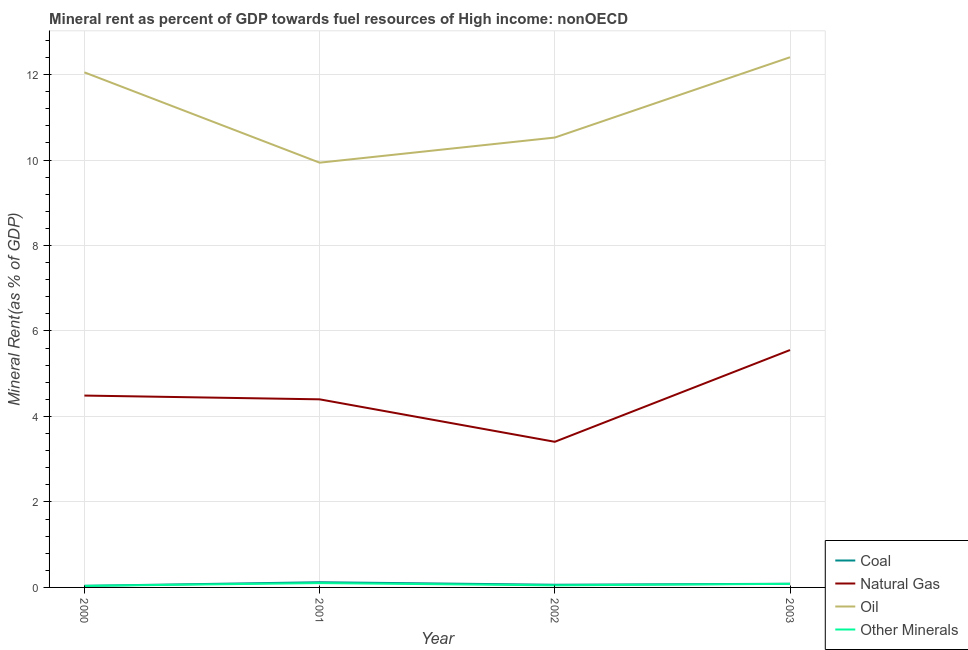How many different coloured lines are there?
Offer a very short reply. 4. What is the natural gas rent in 2001?
Offer a terse response. 4.4. Across all years, what is the maximum coal rent?
Your response must be concise. 0.12. Across all years, what is the minimum coal rent?
Give a very brief answer. 0.04. In which year was the coal rent maximum?
Make the answer very short. 2001. In which year was the oil rent minimum?
Your response must be concise. 2001. What is the total  rent of other minerals in the graph?
Your answer should be compact. 0.27. What is the difference between the oil rent in 2001 and that in 2002?
Your answer should be compact. -0.59. What is the difference between the oil rent in 2000 and the natural gas rent in 2003?
Keep it short and to the point. 6.5. What is the average  rent of other minerals per year?
Ensure brevity in your answer.  0.07. In the year 2000, what is the difference between the natural gas rent and coal rent?
Give a very brief answer. 4.45. In how many years, is the  rent of other minerals greater than 8.4 %?
Offer a terse response. 0. What is the ratio of the coal rent in 2000 to that in 2003?
Your response must be concise. 0.43. What is the difference between the highest and the second highest oil rent?
Make the answer very short. 0.35. What is the difference between the highest and the lowest coal rent?
Make the answer very short. 0.08. In how many years, is the  rent of other minerals greater than the average  rent of other minerals taken over all years?
Provide a short and direct response. 2. Is it the case that in every year, the sum of the coal rent and natural gas rent is greater than the oil rent?
Ensure brevity in your answer.  No. Is the natural gas rent strictly less than the coal rent over the years?
Your answer should be compact. No. How many years are there in the graph?
Your answer should be very brief. 4. Where does the legend appear in the graph?
Offer a terse response. Bottom right. What is the title of the graph?
Provide a succinct answer. Mineral rent as percent of GDP towards fuel resources of High income: nonOECD. What is the label or title of the X-axis?
Offer a very short reply. Year. What is the label or title of the Y-axis?
Keep it short and to the point. Mineral Rent(as % of GDP). What is the Mineral Rent(as % of GDP) in Coal in 2000?
Your answer should be compact. 0.04. What is the Mineral Rent(as % of GDP) in Natural Gas in 2000?
Offer a very short reply. 4.49. What is the Mineral Rent(as % of GDP) of Oil in 2000?
Keep it short and to the point. 12.05. What is the Mineral Rent(as % of GDP) of Other Minerals in 2000?
Offer a terse response. 0.04. What is the Mineral Rent(as % of GDP) of Coal in 2001?
Provide a short and direct response. 0.12. What is the Mineral Rent(as % of GDP) of Natural Gas in 2001?
Provide a short and direct response. 4.4. What is the Mineral Rent(as % of GDP) in Oil in 2001?
Your answer should be very brief. 9.94. What is the Mineral Rent(as % of GDP) in Other Minerals in 2001?
Give a very brief answer. 0.1. What is the Mineral Rent(as % of GDP) of Coal in 2002?
Make the answer very short. 0.06. What is the Mineral Rent(as % of GDP) in Natural Gas in 2002?
Your response must be concise. 3.41. What is the Mineral Rent(as % of GDP) of Oil in 2002?
Make the answer very short. 10.53. What is the Mineral Rent(as % of GDP) in Other Minerals in 2002?
Make the answer very short. 0.05. What is the Mineral Rent(as % of GDP) in Coal in 2003?
Provide a short and direct response. 0.09. What is the Mineral Rent(as % of GDP) of Natural Gas in 2003?
Make the answer very short. 5.55. What is the Mineral Rent(as % of GDP) in Oil in 2003?
Your answer should be compact. 12.4. What is the Mineral Rent(as % of GDP) in Other Minerals in 2003?
Your answer should be very brief. 0.08. Across all years, what is the maximum Mineral Rent(as % of GDP) in Coal?
Your response must be concise. 0.12. Across all years, what is the maximum Mineral Rent(as % of GDP) of Natural Gas?
Provide a succinct answer. 5.55. Across all years, what is the maximum Mineral Rent(as % of GDP) of Oil?
Make the answer very short. 12.4. Across all years, what is the maximum Mineral Rent(as % of GDP) in Other Minerals?
Give a very brief answer. 0.1. Across all years, what is the minimum Mineral Rent(as % of GDP) of Coal?
Make the answer very short. 0.04. Across all years, what is the minimum Mineral Rent(as % of GDP) of Natural Gas?
Give a very brief answer. 3.41. Across all years, what is the minimum Mineral Rent(as % of GDP) in Oil?
Your answer should be very brief. 9.94. Across all years, what is the minimum Mineral Rent(as % of GDP) of Other Minerals?
Offer a very short reply. 0.04. What is the total Mineral Rent(as % of GDP) in Coal in the graph?
Make the answer very short. 0.31. What is the total Mineral Rent(as % of GDP) of Natural Gas in the graph?
Make the answer very short. 17.85. What is the total Mineral Rent(as % of GDP) in Oil in the graph?
Your answer should be compact. 44.92. What is the total Mineral Rent(as % of GDP) in Other Minerals in the graph?
Provide a short and direct response. 0.27. What is the difference between the Mineral Rent(as % of GDP) of Coal in 2000 and that in 2001?
Provide a short and direct response. -0.08. What is the difference between the Mineral Rent(as % of GDP) of Natural Gas in 2000 and that in 2001?
Ensure brevity in your answer.  0.09. What is the difference between the Mineral Rent(as % of GDP) of Oil in 2000 and that in 2001?
Provide a succinct answer. 2.11. What is the difference between the Mineral Rent(as % of GDP) of Other Minerals in 2000 and that in 2001?
Keep it short and to the point. -0.07. What is the difference between the Mineral Rent(as % of GDP) in Coal in 2000 and that in 2002?
Offer a terse response. -0.03. What is the difference between the Mineral Rent(as % of GDP) in Natural Gas in 2000 and that in 2002?
Keep it short and to the point. 1.08. What is the difference between the Mineral Rent(as % of GDP) in Oil in 2000 and that in 2002?
Make the answer very short. 1.53. What is the difference between the Mineral Rent(as % of GDP) in Other Minerals in 2000 and that in 2002?
Your response must be concise. -0.01. What is the difference between the Mineral Rent(as % of GDP) in Coal in 2000 and that in 2003?
Make the answer very short. -0.05. What is the difference between the Mineral Rent(as % of GDP) in Natural Gas in 2000 and that in 2003?
Offer a terse response. -1.07. What is the difference between the Mineral Rent(as % of GDP) in Oil in 2000 and that in 2003?
Ensure brevity in your answer.  -0.35. What is the difference between the Mineral Rent(as % of GDP) in Other Minerals in 2000 and that in 2003?
Give a very brief answer. -0.05. What is the difference between the Mineral Rent(as % of GDP) in Coal in 2001 and that in 2002?
Make the answer very short. 0.06. What is the difference between the Mineral Rent(as % of GDP) of Natural Gas in 2001 and that in 2002?
Your answer should be very brief. 0.99. What is the difference between the Mineral Rent(as % of GDP) of Oil in 2001 and that in 2002?
Provide a succinct answer. -0.59. What is the difference between the Mineral Rent(as % of GDP) of Other Minerals in 2001 and that in 2002?
Offer a very short reply. 0.05. What is the difference between the Mineral Rent(as % of GDP) in Coal in 2001 and that in 2003?
Your answer should be compact. 0.04. What is the difference between the Mineral Rent(as % of GDP) in Natural Gas in 2001 and that in 2003?
Ensure brevity in your answer.  -1.15. What is the difference between the Mineral Rent(as % of GDP) in Oil in 2001 and that in 2003?
Provide a short and direct response. -2.47. What is the difference between the Mineral Rent(as % of GDP) in Other Minerals in 2001 and that in 2003?
Provide a short and direct response. 0.02. What is the difference between the Mineral Rent(as % of GDP) of Coal in 2002 and that in 2003?
Offer a very short reply. -0.02. What is the difference between the Mineral Rent(as % of GDP) of Natural Gas in 2002 and that in 2003?
Provide a short and direct response. -2.15. What is the difference between the Mineral Rent(as % of GDP) of Oil in 2002 and that in 2003?
Keep it short and to the point. -1.88. What is the difference between the Mineral Rent(as % of GDP) of Other Minerals in 2002 and that in 2003?
Your answer should be very brief. -0.04. What is the difference between the Mineral Rent(as % of GDP) of Coal in 2000 and the Mineral Rent(as % of GDP) of Natural Gas in 2001?
Your response must be concise. -4.36. What is the difference between the Mineral Rent(as % of GDP) in Coal in 2000 and the Mineral Rent(as % of GDP) in Oil in 2001?
Provide a short and direct response. -9.9. What is the difference between the Mineral Rent(as % of GDP) of Coal in 2000 and the Mineral Rent(as % of GDP) of Other Minerals in 2001?
Give a very brief answer. -0.06. What is the difference between the Mineral Rent(as % of GDP) of Natural Gas in 2000 and the Mineral Rent(as % of GDP) of Oil in 2001?
Provide a succinct answer. -5.45. What is the difference between the Mineral Rent(as % of GDP) in Natural Gas in 2000 and the Mineral Rent(as % of GDP) in Other Minerals in 2001?
Give a very brief answer. 4.39. What is the difference between the Mineral Rent(as % of GDP) of Oil in 2000 and the Mineral Rent(as % of GDP) of Other Minerals in 2001?
Provide a short and direct response. 11.95. What is the difference between the Mineral Rent(as % of GDP) in Coal in 2000 and the Mineral Rent(as % of GDP) in Natural Gas in 2002?
Ensure brevity in your answer.  -3.37. What is the difference between the Mineral Rent(as % of GDP) of Coal in 2000 and the Mineral Rent(as % of GDP) of Oil in 2002?
Ensure brevity in your answer.  -10.49. What is the difference between the Mineral Rent(as % of GDP) of Coal in 2000 and the Mineral Rent(as % of GDP) of Other Minerals in 2002?
Your answer should be compact. -0.01. What is the difference between the Mineral Rent(as % of GDP) in Natural Gas in 2000 and the Mineral Rent(as % of GDP) in Oil in 2002?
Give a very brief answer. -6.04. What is the difference between the Mineral Rent(as % of GDP) of Natural Gas in 2000 and the Mineral Rent(as % of GDP) of Other Minerals in 2002?
Give a very brief answer. 4.44. What is the difference between the Mineral Rent(as % of GDP) of Oil in 2000 and the Mineral Rent(as % of GDP) of Other Minerals in 2002?
Provide a succinct answer. 12. What is the difference between the Mineral Rent(as % of GDP) in Coal in 2000 and the Mineral Rent(as % of GDP) in Natural Gas in 2003?
Provide a short and direct response. -5.52. What is the difference between the Mineral Rent(as % of GDP) of Coal in 2000 and the Mineral Rent(as % of GDP) of Oil in 2003?
Offer a terse response. -12.37. What is the difference between the Mineral Rent(as % of GDP) in Coal in 2000 and the Mineral Rent(as % of GDP) in Other Minerals in 2003?
Make the answer very short. -0.05. What is the difference between the Mineral Rent(as % of GDP) in Natural Gas in 2000 and the Mineral Rent(as % of GDP) in Oil in 2003?
Make the answer very short. -7.92. What is the difference between the Mineral Rent(as % of GDP) in Natural Gas in 2000 and the Mineral Rent(as % of GDP) in Other Minerals in 2003?
Your answer should be very brief. 4.41. What is the difference between the Mineral Rent(as % of GDP) in Oil in 2000 and the Mineral Rent(as % of GDP) in Other Minerals in 2003?
Your response must be concise. 11.97. What is the difference between the Mineral Rent(as % of GDP) in Coal in 2001 and the Mineral Rent(as % of GDP) in Natural Gas in 2002?
Offer a very short reply. -3.29. What is the difference between the Mineral Rent(as % of GDP) of Coal in 2001 and the Mineral Rent(as % of GDP) of Oil in 2002?
Your answer should be compact. -10.4. What is the difference between the Mineral Rent(as % of GDP) in Coal in 2001 and the Mineral Rent(as % of GDP) in Other Minerals in 2002?
Offer a very short reply. 0.07. What is the difference between the Mineral Rent(as % of GDP) of Natural Gas in 2001 and the Mineral Rent(as % of GDP) of Oil in 2002?
Provide a short and direct response. -6.12. What is the difference between the Mineral Rent(as % of GDP) in Natural Gas in 2001 and the Mineral Rent(as % of GDP) in Other Minerals in 2002?
Your answer should be very brief. 4.35. What is the difference between the Mineral Rent(as % of GDP) in Oil in 2001 and the Mineral Rent(as % of GDP) in Other Minerals in 2002?
Offer a terse response. 9.89. What is the difference between the Mineral Rent(as % of GDP) of Coal in 2001 and the Mineral Rent(as % of GDP) of Natural Gas in 2003?
Provide a succinct answer. -5.43. What is the difference between the Mineral Rent(as % of GDP) of Coal in 2001 and the Mineral Rent(as % of GDP) of Oil in 2003?
Offer a very short reply. -12.28. What is the difference between the Mineral Rent(as % of GDP) in Coal in 2001 and the Mineral Rent(as % of GDP) in Other Minerals in 2003?
Provide a short and direct response. 0.04. What is the difference between the Mineral Rent(as % of GDP) of Natural Gas in 2001 and the Mineral Rent(as % of GDP) of Oil in 2003?
Give a very brief answer. -8. What is the difference between the Mineral Rent(as % of GDP) of Natural Gas in 2001 and the Mineral Rent(as % of GDP) of Other Minerals in 2003?
Give a very brief answer. 4.32. What is the difference between the Mineral Rent(as % of GDP) of Oil in 2001 and the Mineral Rent(as % of GDP) of Other Minerals in 2003?
Your answer should be very brief. 9.85. What is the difference between the Mineral Rent(as % of GDP) in Coal in 2002 and the Mineral Rent(as % of GDP) in Natural Gas in 2003?
Provide a succinct answer. -5.49. What is the difference between the Mineral Rent(as % of GDP) of Coal in 2002 and the Mineral Rent(as % of GDP) of Oil in 2003?
Make the answer very short. -12.34. What is the difference between the Mineral Rent(as % of GDP) of Coal in 2002 and the Mineral Rent(as % of GDP) of Other Minerals in 2003?
Your answer should be compact. -0.02. What is the difference between the Mineral Rent(as % of GDP) of Natural Gas in 2002 and the Mineral Rent(as % of GDP) of Oil in 2003?
Provide a succinct answer. -9. What is the difference between the Mineral Rent(as % of GDP) of Natural Gas in 2002 and the Mineral Rent(as % of GDP) of Other Minerals in 2003?
Provide a short and direct response. 3.32. What is the difference between the Mineral Rent(as % of GDP) in Oil in 2002 and the Mineral Rent(as % of GDP) in Other Minerals in 2003?
Give a very brief answer. 10.44. What is the average Mineral Rent(as % of GDP) in Coal per year?
Give a very brief answer. 0.08. What is the average Mineral Rent(as % of GDP) of Natural Gas per year?
Make the answer very short. 4.46. What is the average Mineral Rent(as % of GDP) in Oil per year?
Offer a terse response. 11.23. What is the average Mineral Rent(as % of GDP) of Other Minerals per year?
Offer a terse response. 0.07. In the year 2000, what is the difference between the Mineral Rent(as % of GDP) of Coal and Mineral Rent(as % of GDP) of Natural Gas?
Give a very brief answer. -4.45. In the year 2000, what is the difference between the Mineral Rent(as % of GDP) of Coal and Mineral Rent(as % of GDP) of Oil?
Make the answer very short. -12.01. In the year 2000, what is the difference between the Mineral Rent(as % of GDP) in Coal and Mineral Rent(as % of GDP) in Other Minerals?
Provide a short and direct response. 0. In the year 2000, what is the difference between the Mineral Rent(as % of GDP) in Natural Gas and Mineral Rent(as % of GDP) in Oil?
Provide a succinct answer. -7.56. In the year 2000, what is the difference between the Mineral Rent(as % of GDP) in Natural Gas and Mineral Rent(as % of GDP) in Other Minerals?
Provide a succinct answer. 4.45. In the year 2000, what is the difference between the Mineral Rent(as % of GDP) in Oil and Mineral Rent(as % of GDP) in Other Minerals?
Make the answer very short. 12.02. In the year 2001, what is the difference between the Mineral Rent(as % of GDP) of Coal and Mineral Rent(as % of GDP) of Natural Gas?
Give a very brief answer. -4.28. In the year 2001, what is the difference between the Mineral Rent(as % of GDP) in Coal and Mineral Rent(as % of GDP) in Oil?
Offer a terse response. -9.82. In the year 2001, what is the difference between the Mineral Rent(as % of GDP) of Coal and Mineral Rent(as % of GDP) of Other Minerals?
Offer a terse response. 0.02. In the year 2001, what is the difference between the Mineral Rent(as % of GDP) of Natural Gas and Mineral Rent(as % of GDP) of Oil?
Give a very brief answer. -5.54. In the year 2001, what is the difference between the Mineral Rent(as % of GDP) of Natural Gas and Mineral Rent(as % of GDP) of Other Minerals?
Give a very brief answer. 4.3. In the year 2001, what is the difference between the Mineral Rent(as % of GDP) in Oil and Mineral Rent(as % of GDP) in Other Minerals?
Your answer should be compact. 9.84. In the year 2002, what is the difference between the Mineral Rent(as % of GDP) of Coal and Mineral Rent(as % of GDP) of Natural Gas?
Your answer should be very brief. -3.34. In the year 2002, what is the difference between the Mineral Rent(as % of GDP) of Coal and Mineral Rent(as % of GDP) of Oil?
Ensure brevity in your answer.  -10.46. In the year 2002, what is the difference between the Mineral Rent(as % of GDP) of Coal and Mineral Rent(as % of GDP) of Other Minerals?
Your response must be concise. 0.01. In the year 2002, what is the difference between the Mineral Rent(as % of GDP) in Natural Gas and Mineral Rent(as % of GDP) in Oil?
Offer a terse response. -7.12. In the year 2002, what is the difference between the Mineral Rent(as % of GDP) of Natural Gas and Mineral Rent(as % of GDP) of Other Minerals?
Make the answer very short. 3.36. In the year 2002, what is the difference between the Mineral Rent(as % of GDP) in Oil and Mineral Rent(as % of GDP) in Other Minerals?
Your response must be concise. 10.48. In the year 2003, what is the difference between the Mineral Rent(as % of GDP) of Coal and Mineral Rent(as % of GDP) of Natural Gas?
Provide a short and direct response. -5.47. In the year 2003, what is the difference between the Mineral Rent(as % of GDP) in Coal and Mineral Rent(as % of GDP) in Oil?
Provide a succinct answer. -12.32. In the year 2003, what is the difference between the Mineral Rent(as % of GDP) of Coal and Mineral Rent(as % of GDP) of Other Minerals?
Your answer should be very brief. 0. In the year 2003, what is the difference between the Mineral Rent(as % of GDP) of Natural Gas and Mineral Rent(as % of GDP) of Oil?
Provide a succinct answer. -6.85. In the year 2003, what is the difference between the Mineral Rent(as % of GDP) in Natural Gas and Mineral Rent(as % of GDP) in Other Minerals?
Your answer should be very brief. 5.47. In the year 2003, what is the difference between the Mineral Rent(as % of GDP) in Oil and Mineral Rent(as % of GDP) in Other Minerals?
Your answer should be very brief. 12.32. What is the ratio of the Mineral Rent(as % of GDP) in Coal in 2000 to that in 2001?
Your response must be concise. 0.31. What is the ratio of the Mineral Rent(as % of GDP) in Oil in 2000 to that in 2001?
Your response must be concise. 1.21. What is the ratio of the Mineral Rent(as % of GDP) in Other Minerals in 2000 to that in 2001?
Offer a very short reply. 0.36. What is the ratio of the Mineral Rent(as % of GDP) in Coal in 2000 to that in 2002?
Give a very brief answer. 0.6. What is the ratio of the Mineral Rent(as % of GDP) of Natural Gas in 2000 to that in 2002?
Offer a very short reply. 1.32. What is the ratio of the Mineral Rent(as % of GDP) in Oil in 2000 to that in 2002?
Make the answer very short. 1.14. What is the ratio of the Mineral Rent(as % of GDP) in Other Minerals in 2000 to that in 2002?
Keep it short and to the point. 0.75. What is the ratio of the Mineral Rent(as % of GDP) in Coal in 2000 to that in 2003?
Provide a succinct answer. 0.43. What is the ratio of the Mineral Rent(as % of GDP) of Natural Gas in 2000 to that in 2003?
Make the answer very short. 0.81. What is the ratio of the Mineral Rent(as % of GDP) in Oil in 2000 to that in 2003?
Provide a short and direct response. 0.97. What is the ratio of the Mineral Rent(as % of GDP) of Other Minerals in 2000 to that in 2003?
Provide a short and direct response. 0.43. What is the ratio of the Mineral Rent(as % of GDP) in Coal in 2001 to that in 2002?
Keep it short and to the point. 1.94. What is the ratio of the Mineral Rent(as % of GDP) in Natural Gas in 2001 to that in 2002?
Give a very brief answer. 1.29. What is the ratio of the Mineral Rent(as % of GDP) of Oil in 2001 to that in 2002?
Your answer should be very brief. 0.94. What is the ratio of the Mineral Rent(as % of GDP) of Other Minerals in 2001 to that in 2002?
Your answer should be compact. 2.08. What is the ratio of the Mineral Rent(as % of GDP) of Coal in 2001 to that in 2003?
Your answer should be very brief. 1.41. What is the ratio of the Mineral Rent(as % of GDP) of Natural Gas in 2001 to that in 2003?
Give a very brief answer. 0.79. What is the ratio of the Mineral Rent(as % of GDP) of Oil in 2001 to that in 2003?
Offer a terse response. 0.8. What is the ratio of the Mineral Rent(as % of GDP) of Other Minerals in 2001 to that in 2003?
Provide a succinct answer. 1.21. What is the ratio of the Mineral Rent(as % of GDP) of Coal in 2002 to that in 2003?
Your answer should be compact. 0.73. What is the ratio of the Mineral Rent(as % of GDP) in Natural Gas in 2002 to that in 2003?
Your answer should be compact. 0.61. What is the ratio of the Mineral Rent(as % of GDP) of Oil in 2002 to that in 2003?
Keep it short and to the point. 0.85. What is the ratio of the Mineral Rent(as % of GDP) in Other Minerals in 2002 to that in 2003?
Your response must be concise. 0.58. What is the difference between the highest and the second highest Mineral Rent(as % of GDP) in Coal?
Keep it short and to the point. 0.04. What is the difference between the highest and the second highest Mineral Rent(as % of GDP) of Natural Gas?
Provide a succinct answer. 1.07. What is the difference between the highest and the second highest Mineral Rent(as % of GDP) in Oil?
Keep it short and to the point. 0.35. What is the difference between the highest and the second highest Mineral Rent(as % of GDP) of Other Minerals?
Provide a short and direct response. 0.02. What is the difference between the highest and the lowest Mineral Rent(as % of GDP) in Coal?
Provide a short and direct response. 0.08. What is the difference between the highest and the lowest Mineral Rent(as % of GDP) in Natural Gas?
Ensure brevity in your answer.  2.15. What is the difference between the highest and the lowest Mineral Rent(as % of GDP) of Oil?
Keep it short and to the point. 2.47. What is the difference between the highest and the lowest Mineral Rent(as % of GDP) of Other Minerals?
Your answer should be compact. 0.07. 